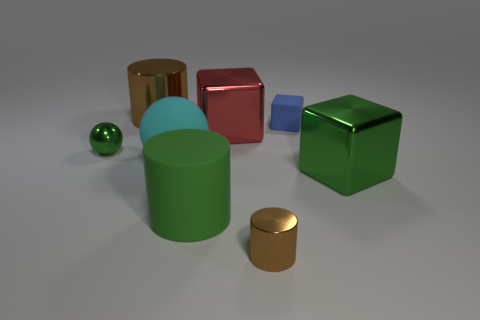There is a brown thing that is the same size as the green sphere; what is its material?
Provide a short and direct response. Metal. How many things are either green metal objects behind the cyan matte sphere or rubber objects left of the small brown shiny cylinder?
Offer a very short reply. 3. Do the metal cylinder that is in front of the green cube and the tiny green thing have the same size?
Make the answer very short. Yes. What is the color of the large metallic cube left of the tiny blue matte cube?
Keep it short and to the point. Red. There is another small metallic object that is the same shape as the cyan thing; what is its color?
Your answer should be very brief. Green. There is a brown metallic thing in front of the large cylinder behind the large green rubber object; what number of shiny cylinders are on the left side of it?
Keep it short and to the point. 1. Are there fewer small metal objects that are behind the large red thing than big purple rubber objects?
Offer a terse response. No. Does the tiny sphere have the same color as the rubber cylinder?
Provide a succinct answer. Yes. What size is the red object that is the same shape as the tiny blue rubber object?
Keep it short and to the point. Large. How many cyan balls are the same material as the green ball?
Offer a very short reply. 0. 